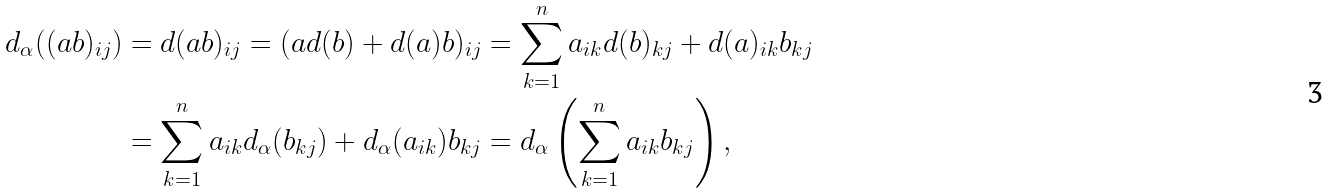Convert formula to latex. <formula><loc_0><loc_0><loc_500><loc_500>d _ { \alpha } ( ( a b ) _ { i j } ) & = d ( a b ) _ { i j } = ( a d ( b ) + d ( a ) b ) _ { i j } = \sum _ { k = 1 } ^ { n } a _ { i k } d ( b ) _ { k j } + d ( a ) _ { i k } b _ { k j } \\ & = \sum _ { k = 1 } ^ { n } a _ { i k } d _ { \alpha } ( b _ { k j } ) + d _ { \alpha } ( a _ { i k } ) b _ { k j } = d _ { \alpha } \left ( \sum _ { k = 1 } ^ { n } a _ { i k } b _ { k j } \right ) ,</formula> 